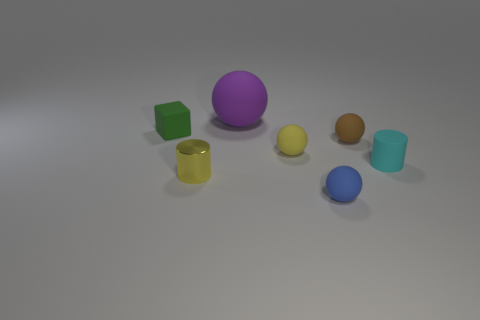How many other objects are the same color as the small metallic thing? Including the small metallic object, there is one item of the same color, which is a larger yellow sphere. It's interesting to note the contrast in sizes and textures between the two yellow objects. 